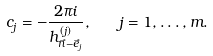<formula> <loc_0><loc_0><loc_500><loc_500>c _ { j } = - \frac { 2 \pi i } { h ^ { ( j ) } _ { \vec { n } - \vec { e } _ { j } } } , \quad j = 1 , \dots , m .</formula> 